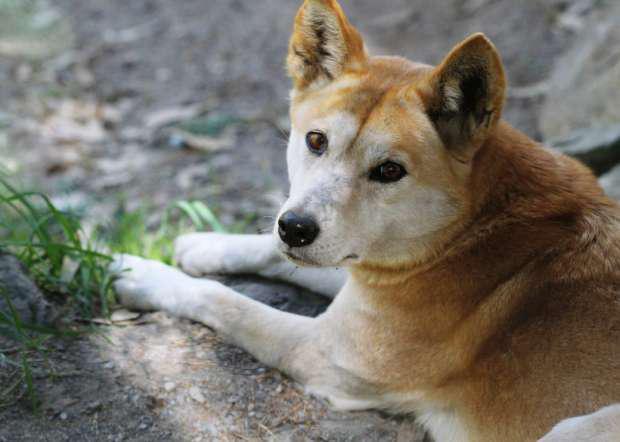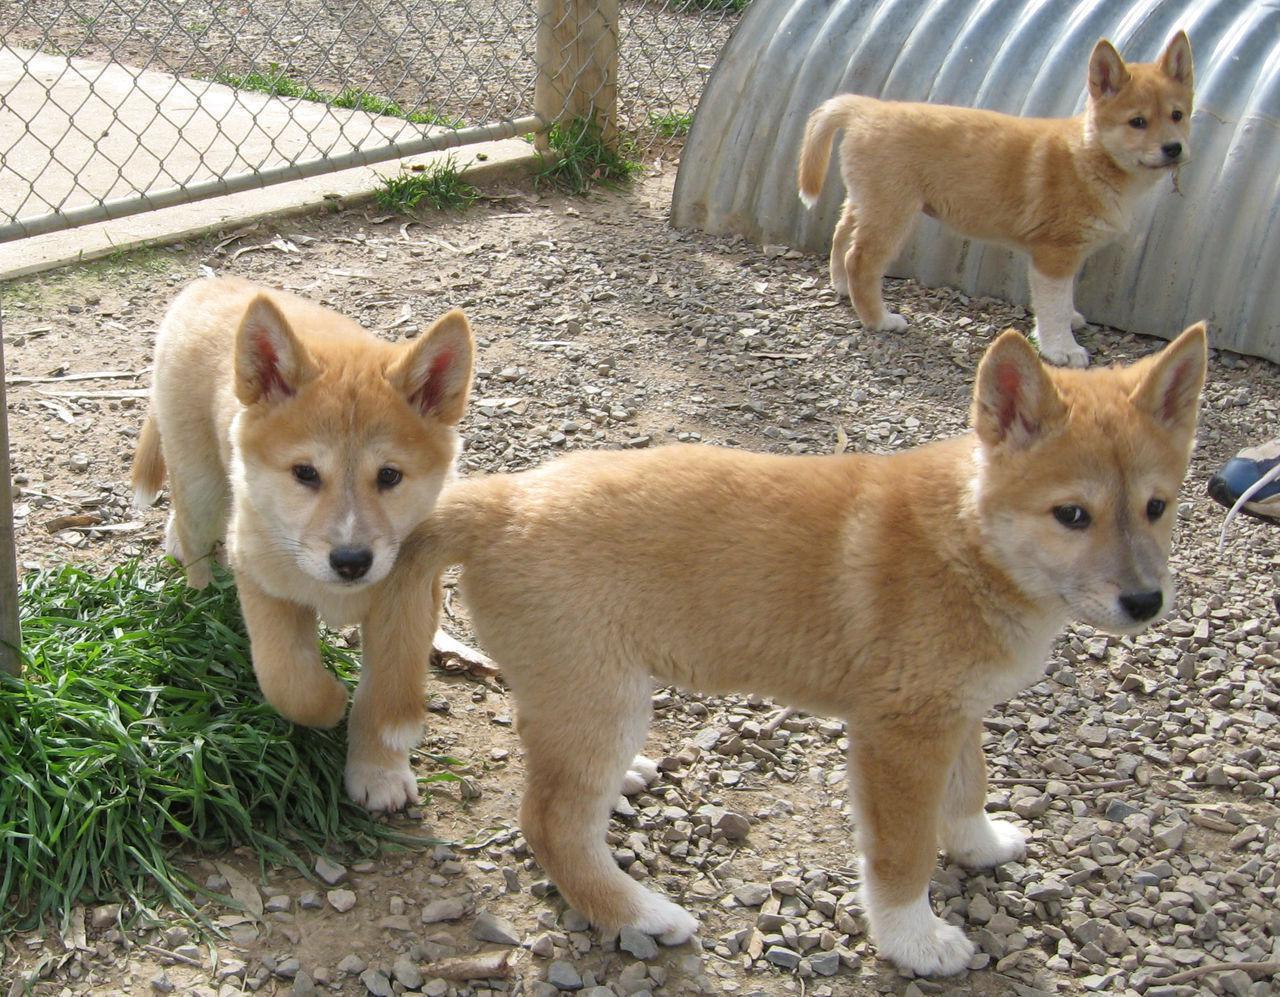The first image is the image on the left, the second image is the image on the right. For the images shown, is this caption "There's a total of 4 dogs on both images." true? Answer yes or no. Yes. 